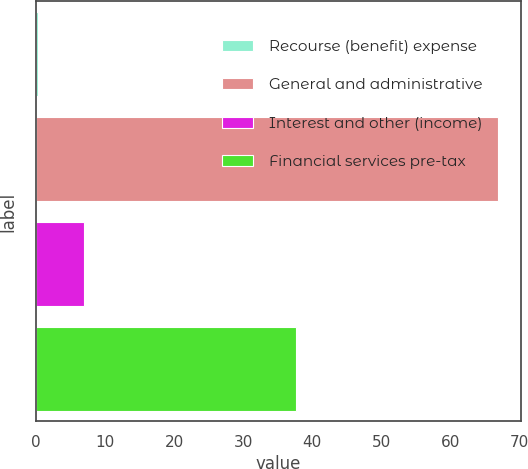Convert chart to OTSL. <chart><loc_0><loc_0><loc_500><loc_500><bar_chart><fcel>Recourse (benefit) expense<fcel>General and administrative<fcel>Interest and other (income)<fcel>Financial services pre-tax<nl><fcel>0.3<fcel>66.9<fcel>6.96<fcel>37.7<nl></chart> 